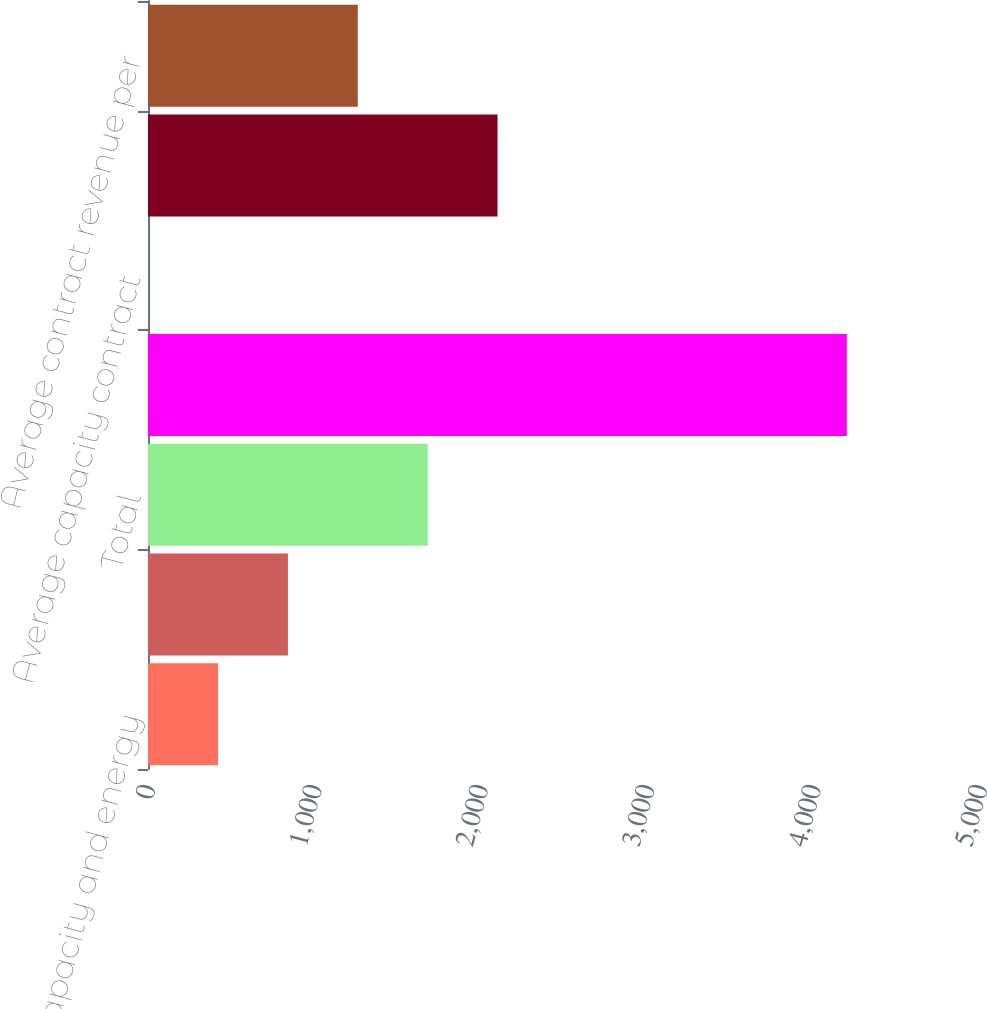<chart> <loc_0><loc_0><loc_500><loc_500><bar_chart><fcel>Bundled capacity and energy<fcel>Capacity contracts<fcel>Total<fcel>Planned net MW in operation<fcel>Average capacity contract<fcel>of planned generation and<fcel>Average contract revenue per<nl><fcel>420.99<fcel>840.88<fcel>1680.66<fcel>4200<fcel>1.1<fcel>2100.55<fcel>1260.77<nl></chart> 